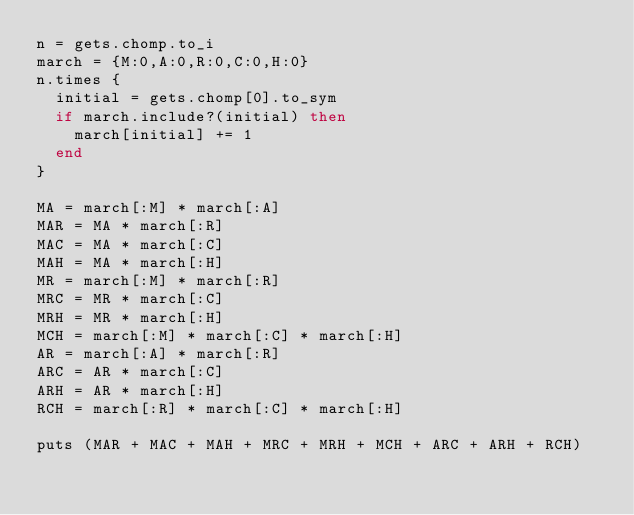<code> <loc_0><loc_0><loc_500><loc_500><_Ruby_>n = gets.chomp.to_i
march = {M:0,A:0,R:0,C:0,H:0}
n.times {
  initial = gets.chomp[0].to_sym
  if march.include?(initial) then
    march[initial] += 1
  end
}

MA = march[:M] * march[:A]
MAR = MA * march[:R]
MAC = MA * march[:C]
MAH = MA * march[:H]
MR = march[:M] * march[:R]
MRC = MR * march[:C]
MRH = MR * march[:H]
MCH = march[:M] * march[:C] * march[:H]
AR = march[:A] * march[:R]
ARC = AR * march[:C]
ARH = AR * march[:H]
RCH = march[:R] * march[:C] * march[:H]

puts (MAR + MAC + MAH + MRC + MRH + MCH + ARC + ARH + RCH)
</code> 